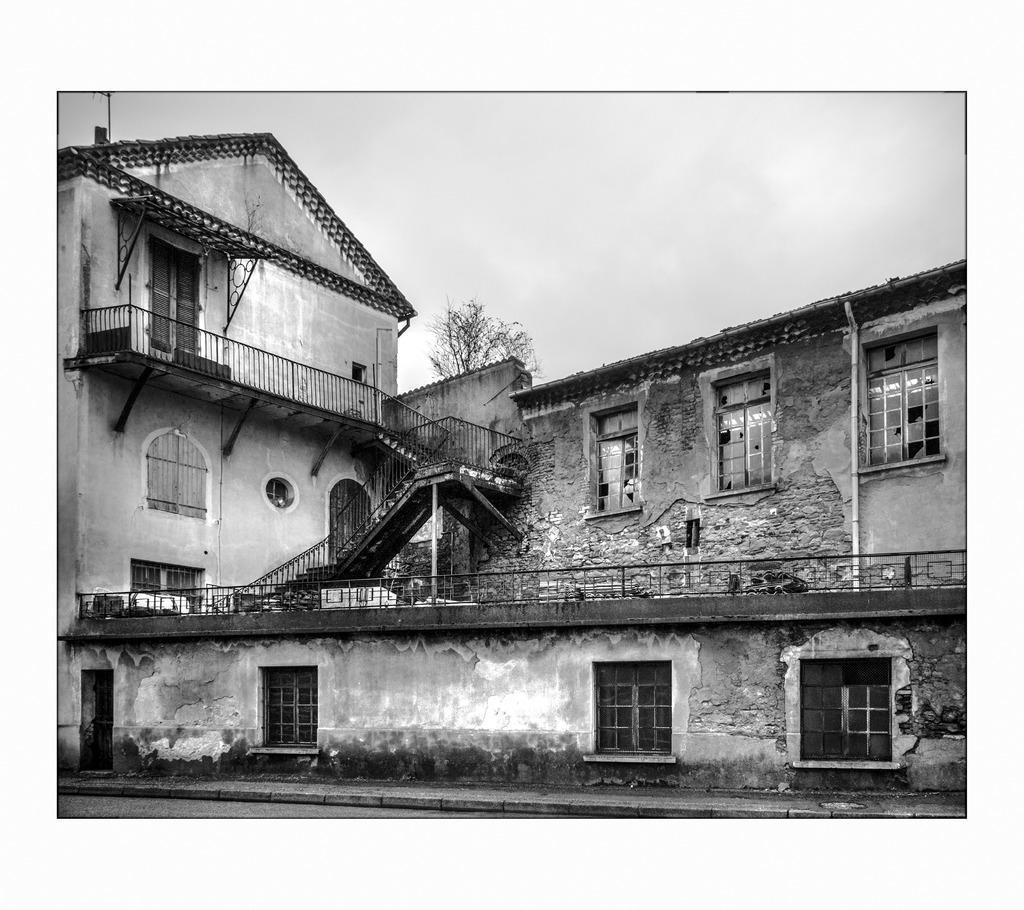Could you give a brief overview of what you see in this image? This is a black and white picture, we can see a building, there are some windows, doors, fence and a tree, in the background we can see the sky. 